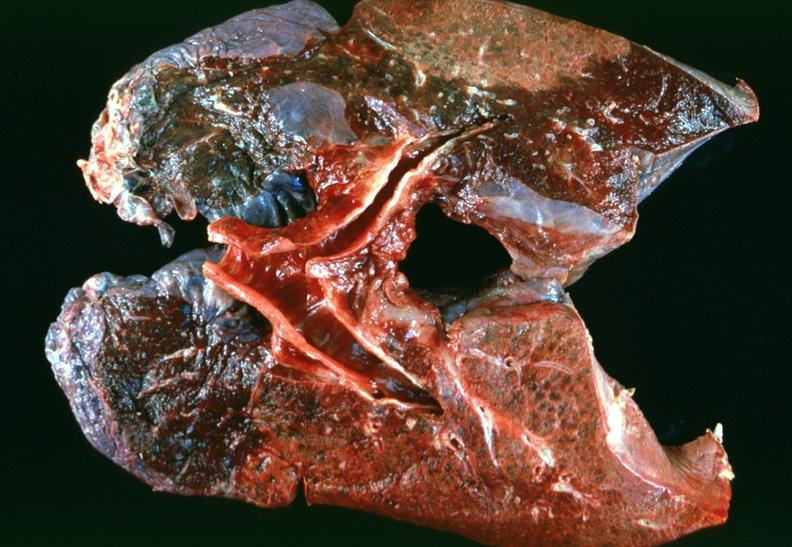where is this?
Answer the question using a single word or phrase. Lung 